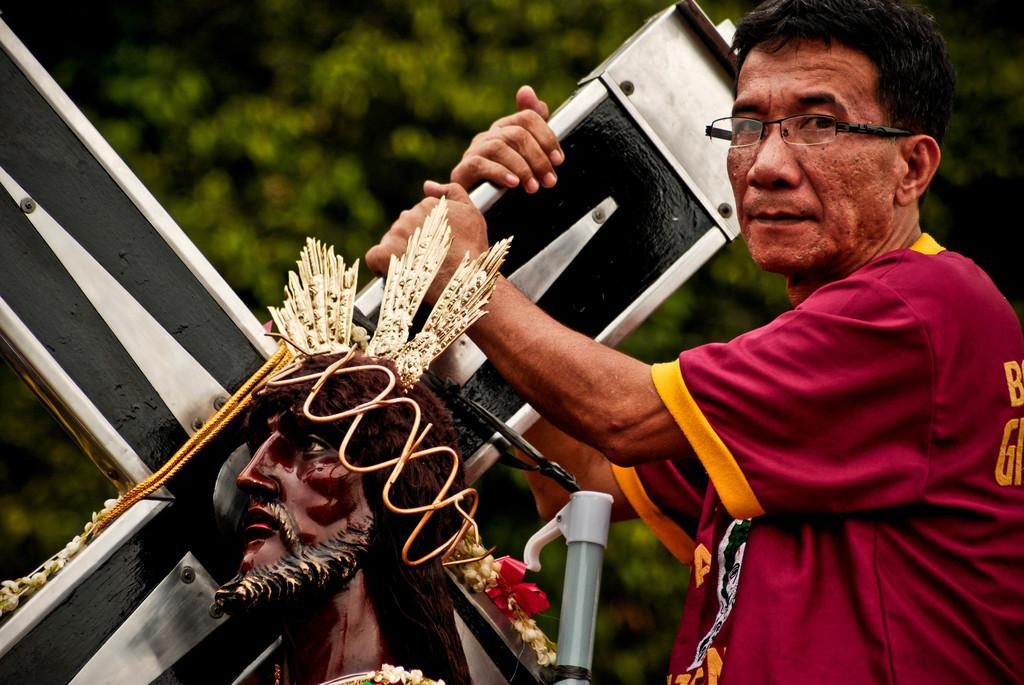What is the main subject of the image? There is a person in the image. What is the person wearing? The person is wearing clothes. What is the person holding in the image? The person is holding a cross with his hands. What can be seen at the bottom of the image? There is a statue at the bottom of the image. How would you describe the background of the image? The background of the image is blurred. What type of chicken is being questioned about death in the image? There is no chicken or any reference to death in the image. 